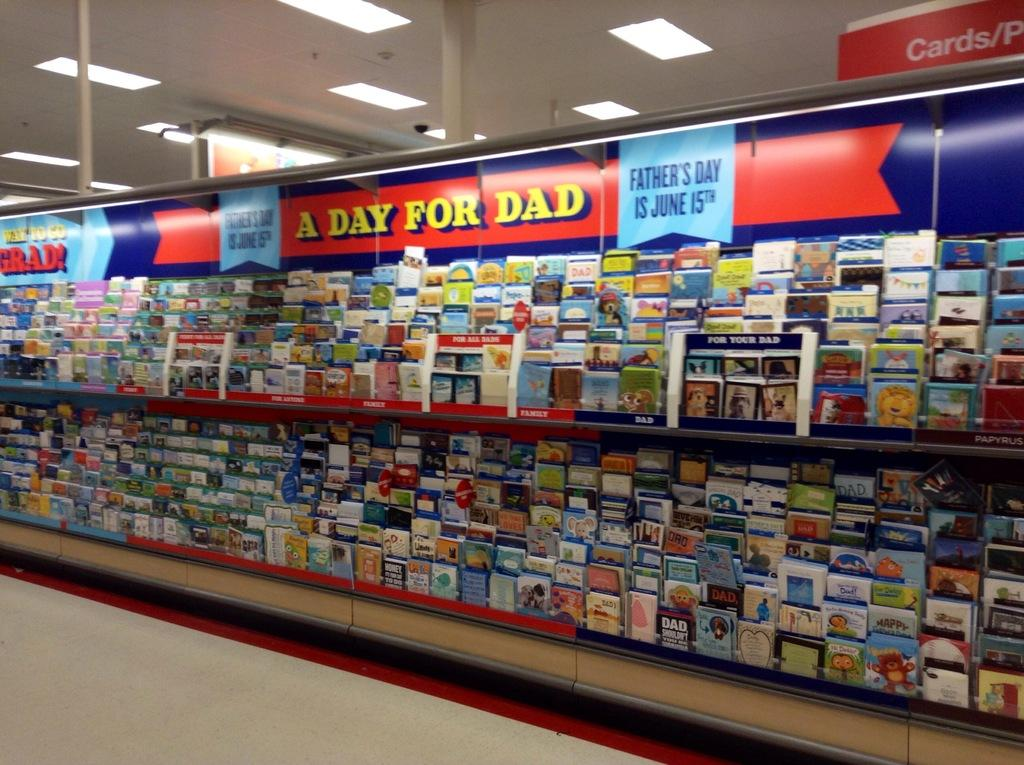Provide a one-sentence caption for the provided image. a greeting card display with a banner that says A DAY FOR DAD on it. 